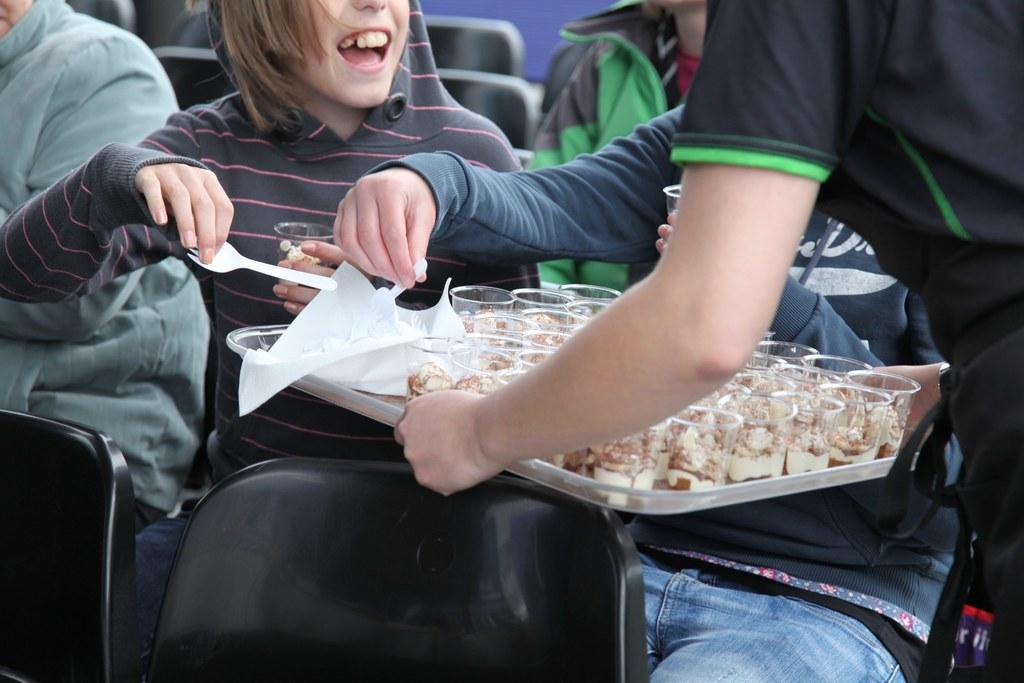What is the person in the image holding? The person is holding a tray in the image. What can be found on the tray? The tray contains cups with sweets. What are the kids in the image doing? The kids are sitting on chairs in the image. What type of apparatus is being used by the kids to perform a science experiment in the image? There is no apparatus or science experiment present in the image; the kids are simply sitting on chairs. How many wheels can be seen on the chairs the kids are sitting on in the image? The chairs in the image do not have wheels; they are stationary. 